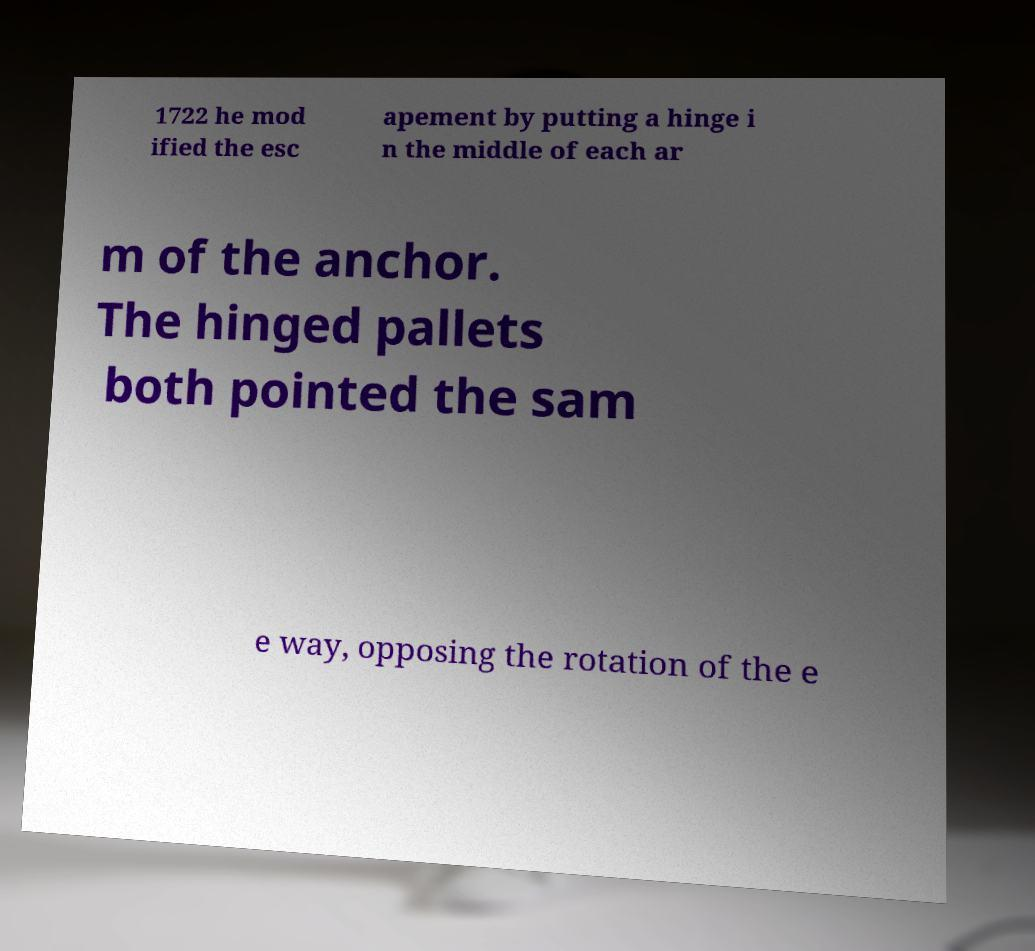Please read and relay the text visible in this image. What does it say? 1722 he mod ified the esc apement by putting a hinge i n the middle of each ar m of the anchor. The hinged pallets both pointed the sam e way, opposing the rotation of the e 